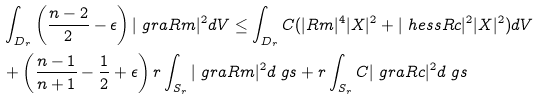<formula> <loc_0><loc_0><loc_500><loc_500>& \int _ { D _ { r } } \left ( \frac { n - 2 } { 2 } - \epsilon \right ) | \ g r a R m | ^ { 2 } d V \leq \int _ { D _ { r } } C ( | R m | ^ { 4 } | X | ^ { 2 } + | \ h e s s R c | ^ { 2 } | X | ^ { 2 } ) d V \\ & + \left ( \frac { n - 1 } { n + 1 } - \frac { 1 } { 2 } + \epsilon \right ) r \int _ { S _ { r } } | \ g r a R m | ^ { 2 } d \ g s + r \int _ { S _ { r } } C | \ g r a R c | ^ { 2 } d \ g s</formula> 